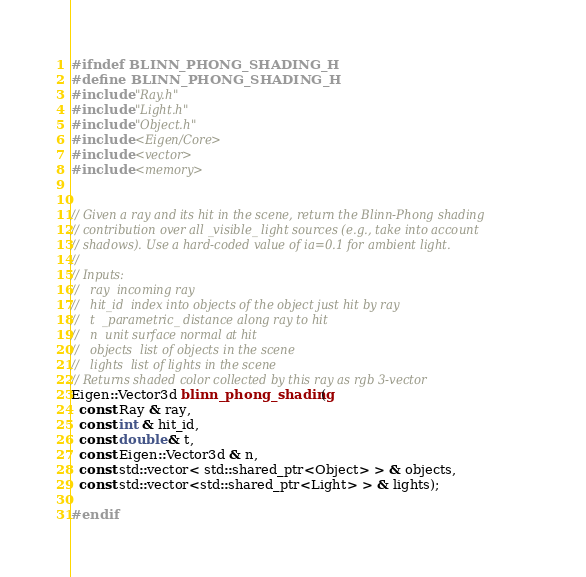<code> <loc_0><loc_0><loc_500><loc_500><_C_>#ifndef BLINN_PHONG_SHADING_H
#define BLINN_PHONG_SHADING_H
#include "Ray.h"
#include "Light.h"
#include "Object.h"
#include <Eigen/Core>
#include <vector>
#include <memory>


// Given a ray and its hit in the scene, return the Blinn-Phong shading
// contribution over all _visible_ light sources (e.g., take into account
// shadows). Use a hard-coded value of ia=0.1 for ambient light.
// 
// Inputs:
//   ray  incoming ray
//   hit_id  index into objects of the object just hit by ray
//   t  _parametric_ distance along ray to hit
//   n  unit surface normal at hit
//   objects  list of objects in the scene
//   lights  list of lights in the scene
// Returns shaded color collected by this ray as rgb 3-vector
Eigen::Vector3d blinn_phong_shading(
  const Ray & ray,
  const int & hit_id, 
  const double & t,
  const Eigen::Vector3d & n,
  const std::vector< std::shared_ptr<Object> > & objects,
  const std::vector<std::shared_ptr<Light> > & lights);

#endif
</code> 